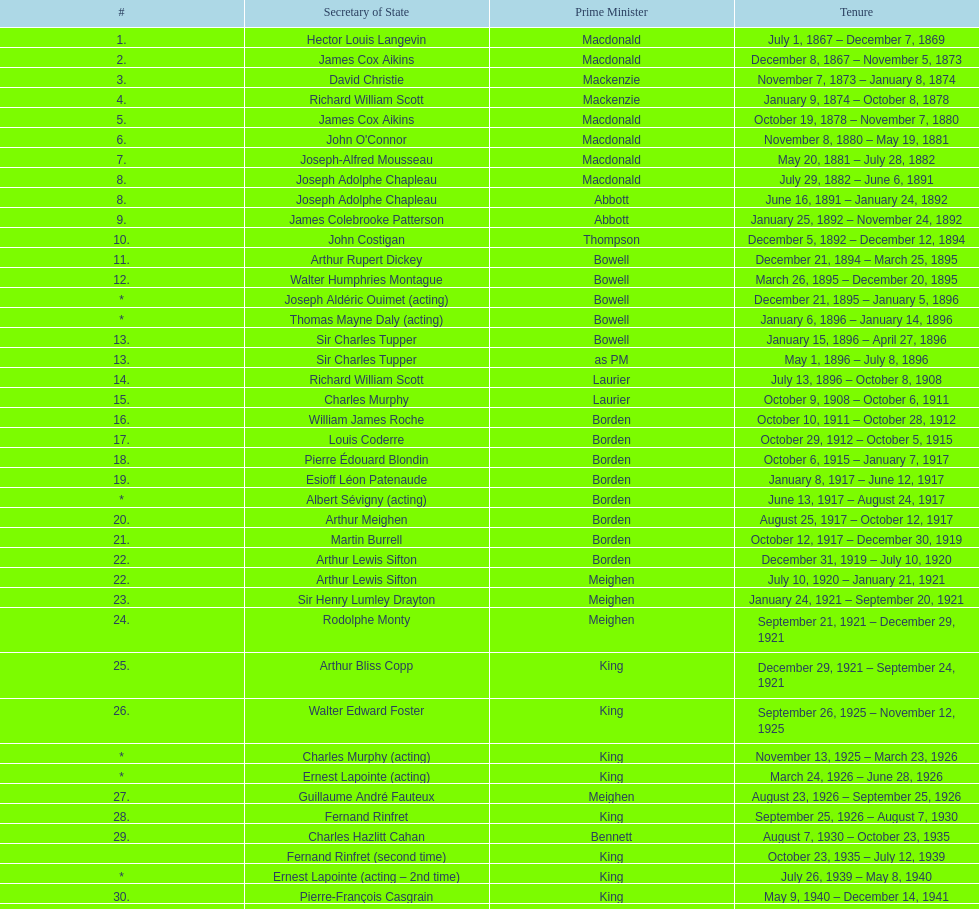Who served as the secretary of state under thompson? John Costigan. 